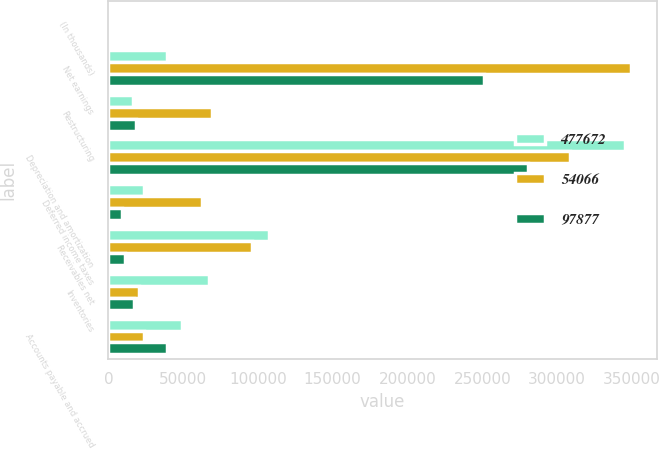<chart> <loc_0><loc_0><loc_500><loc_500><stacked_bar_chart><ecel><fcel>(In thousands)<fcel>Net earnings<fcel>Restructuring<fcel>Depreciation and amortization<fcel>Deferred income taxes<fcel>Receivables net<fcel>Inventories<fcel>Accounts payable and accrued<nl><fcel>477672<fcel>2014<fcel>39181<fcel>16497<fcel>345570<fcel>24026<fcel>107705<fcel>67016<fcel>49204<nl><fcel>54066<fcel>2013<fcel>349291<fcel>69489<fcel>308871<fcel>62525<fcel>96313<fcel>20211<fcel>23921<nl><fcel>97877<fcel>2012<fcel>250893<fcel>18564<fcel>280293<fcel>9037<fcel>10888<fcel>17079<fcel>39181<nl></chart> 